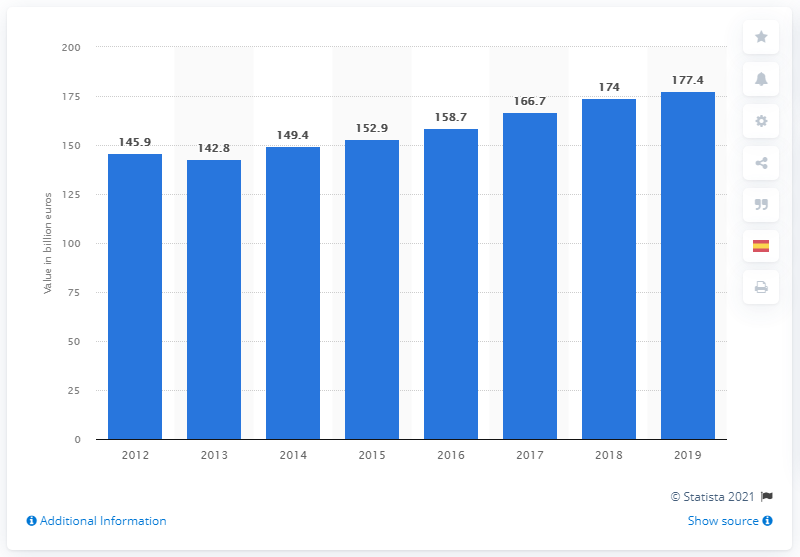Highlight a few significant elements in this photo. In 2019, Spain's GDP contribution was 177.4%. 